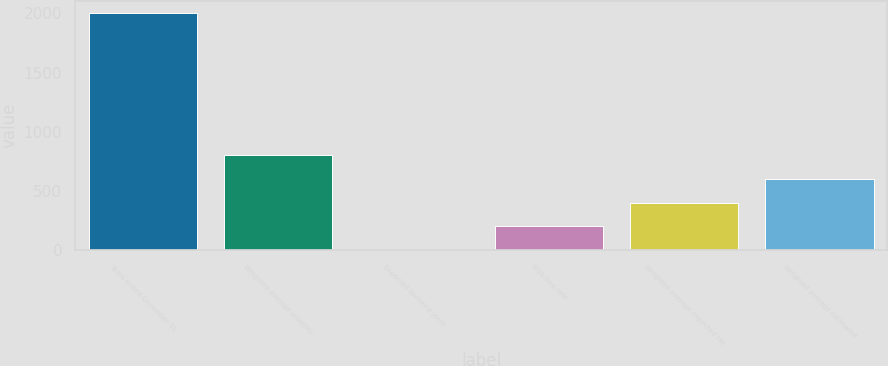Convert chart. <chart><loc_0><loc_0><loc_500><loc_500><bar_chart><fcel>Years ended December 31<fcel>Weighted average volatility<fcel>Expected dividend yield<fcel>Risk-free rate<fcel>Weighted average expected life<fcel>Weighted average estimated<nl><fcel>2007<fcel>803.76<fcel>1.6<fcel>202.14<fcel>402.68<fcel>603.22<nl></chart> 